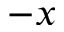Convert formula to latex. <formula><loc_0><loc_0><loc_500><loc_500>- x</formula> 